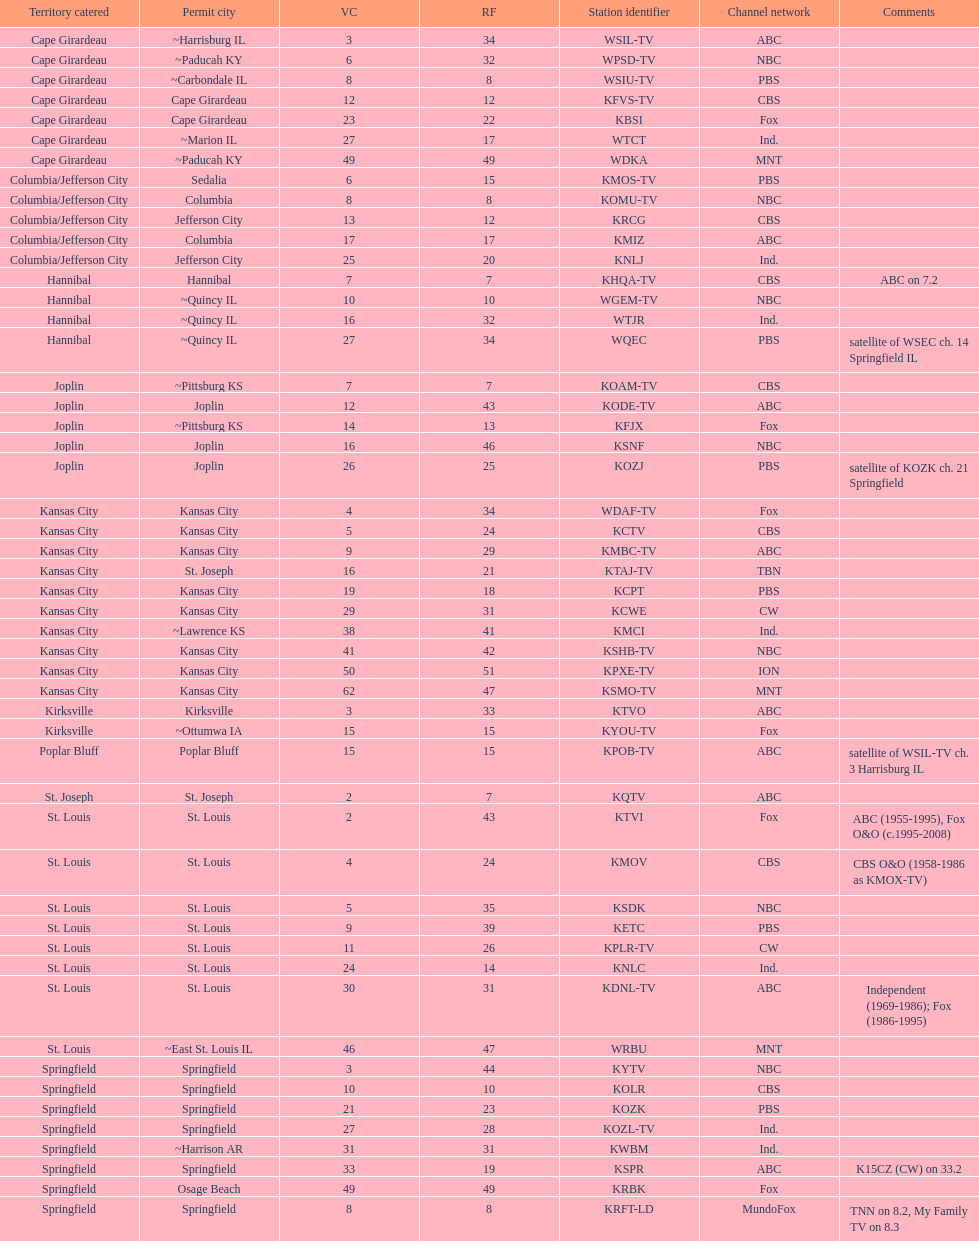How many of these missouri tv stations are actually licensed in a city in illinois (il)? 7. 